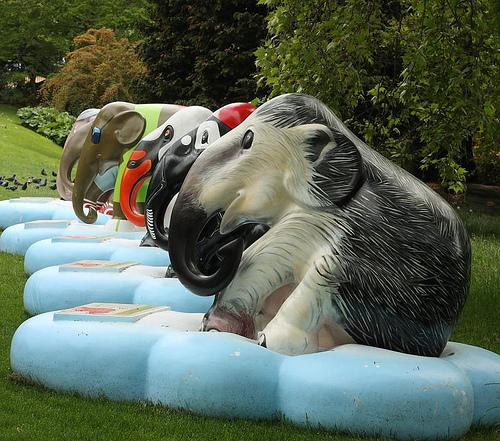Count the number of elephant statues and describe their colors/characteristics. There are five elephant statues: a black and white statue, a red, black, and white statue, an elephant with a red trunk, one with green on its torso, and one last statue. Describe the state and features of the elephant statue with a red trunk. The elephant statue with a red trunk is grey and white, and it has a blue patch on its eye. Describe the color of the trunk of the first elephant statue and the position of the last statue in the line. The trunk of the first elephant statue is black, and the last elephant statue is placed at the end of the line. What is the background of the image comprised of? In the background, there are trees, and birds can be seen walking around on the grass. How many birds are there in the grass and what are they doing? There are five birds in the grass, just walking around behind the elephant statutes. What is the sentiment conveyed by the image? The image conveys a peaceful and artistic sentiment through the statues of elephants and the natural background. Discuss the interaction between the different objects in the image. The elephant statues are positioned in a line, interacting with the peaceful background of trees and bushes, while birds wander around in the grass behind them. Provide a detailed description of the predominant element in the image. There are multiple stone elephants lined up, each elephant statue having varying colors like black and white or red, green, and positioned on blue bases. Briefly describe the color and appearance of the bases on which the elephant statues are placed. The bases of the elephant statues are blue stones. Are there any bushes or trees near the elephant statues? Describe them. Yes, there are bushes on the ground near the statues, and a brown tree is present as well. 